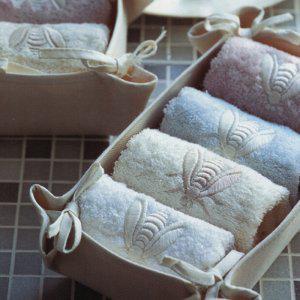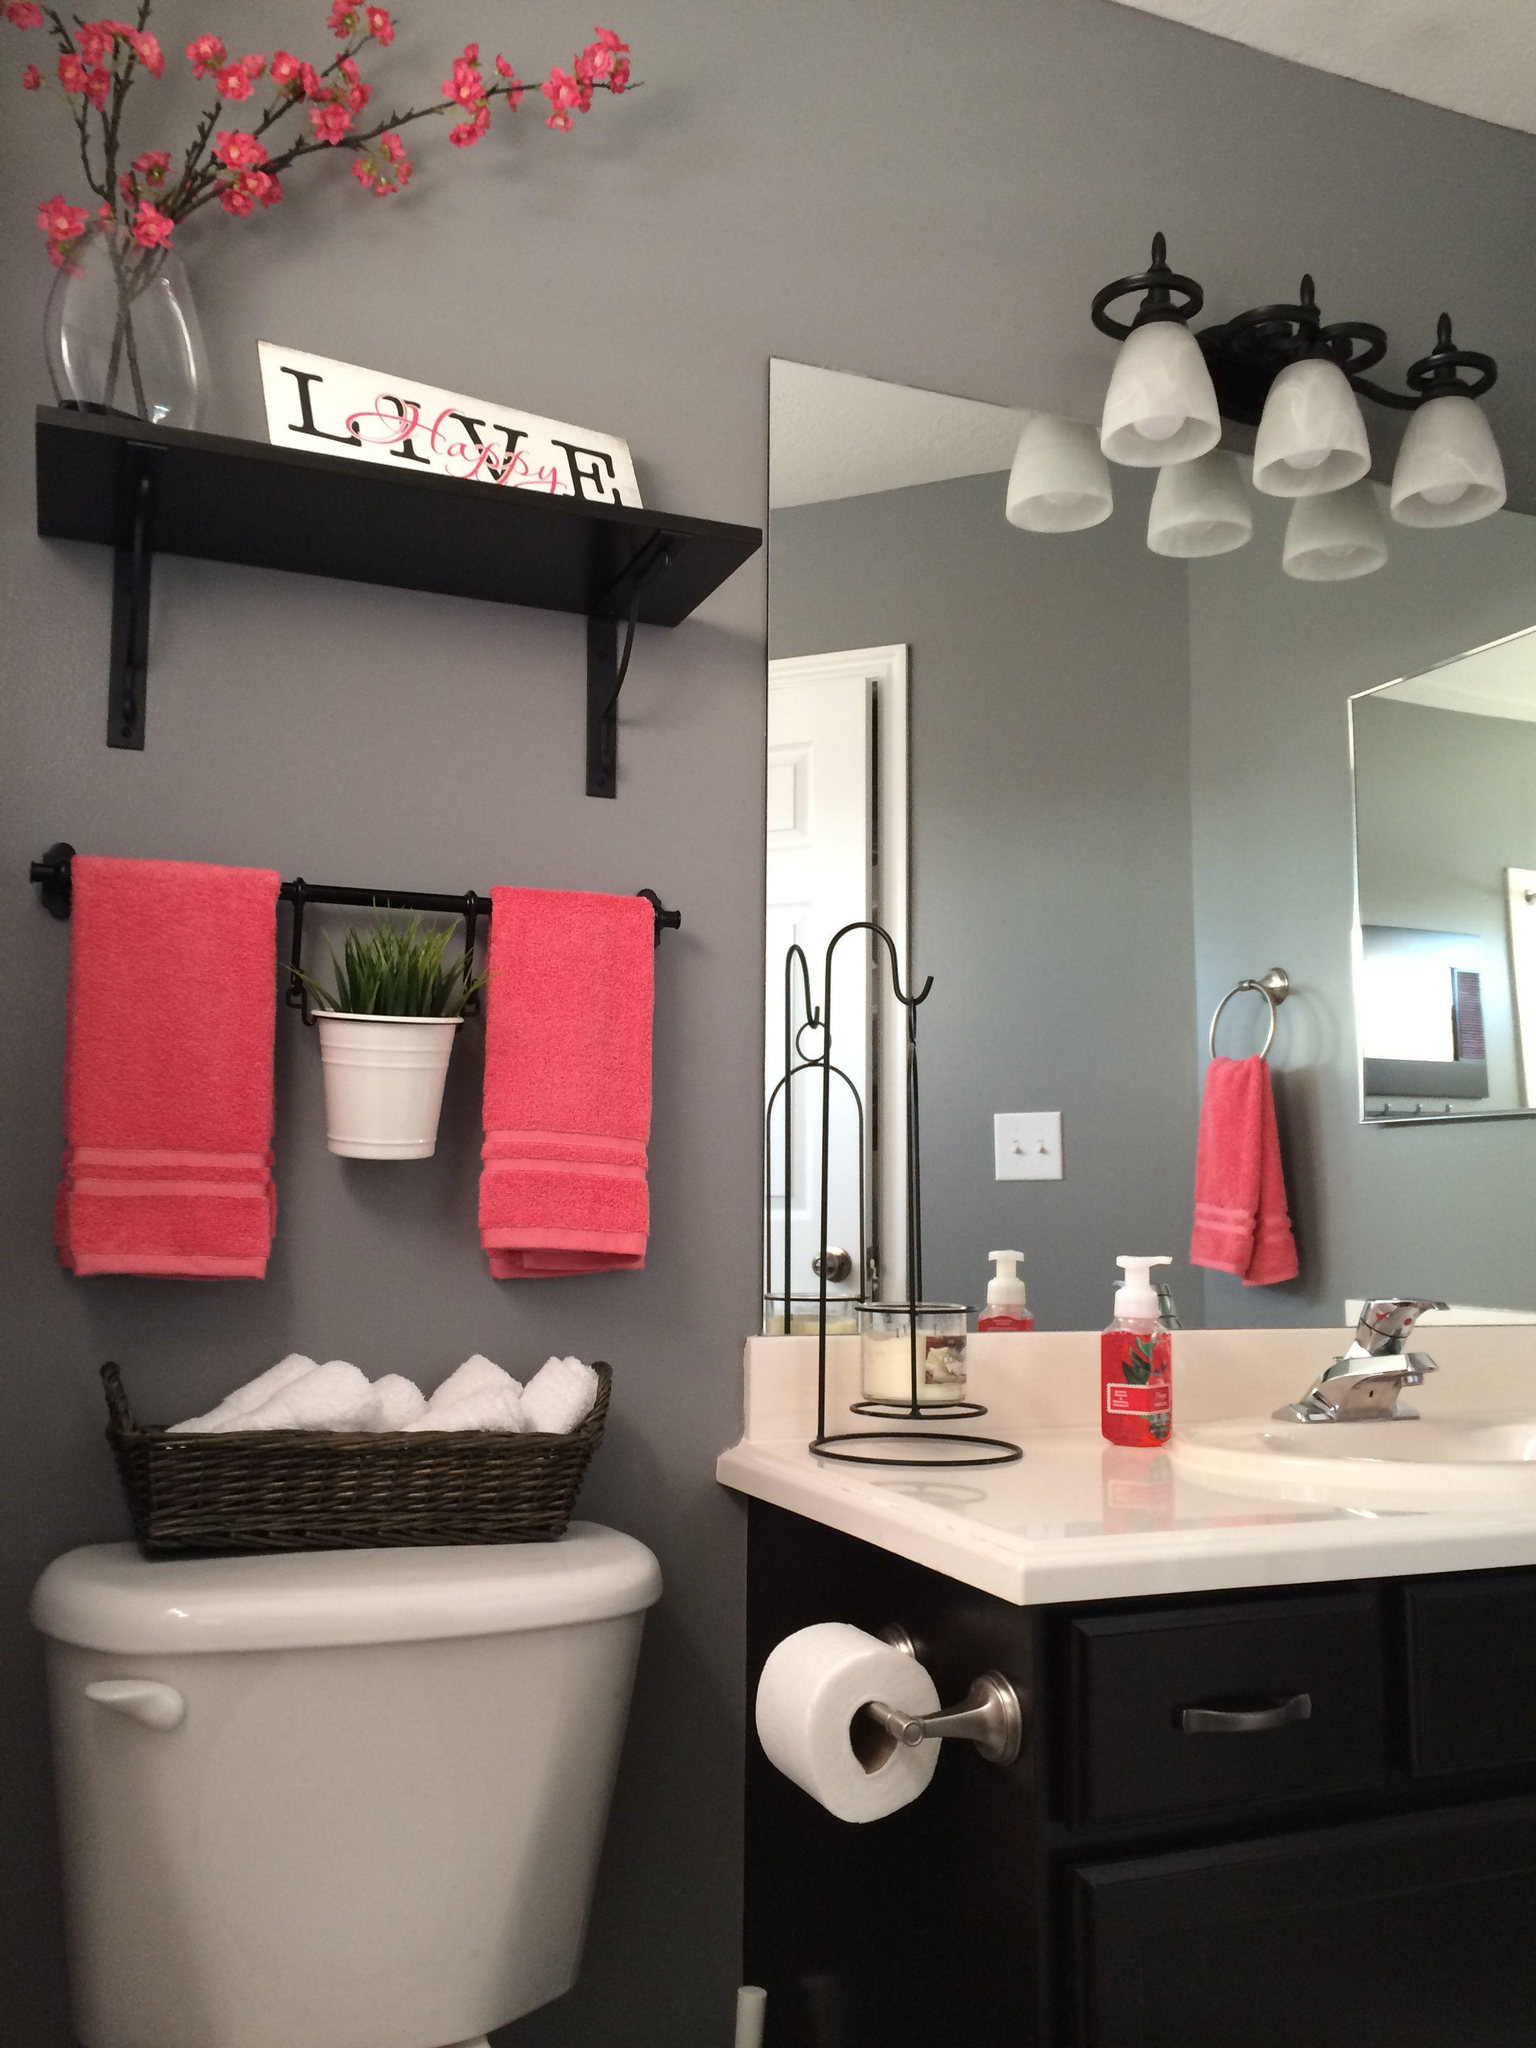The first image is the image on the left, the second image is the image on the right. Evaluate the accuracy of this statement regarding the images: "There are objects sitting on bath towels.". Is it true? Answer yes or no. No. The first image is the image on the left, the second image is the image on the right. Considering the images on both sides, is "A toilet is visible in the right image." valid? Answer yes or no. Yes. 